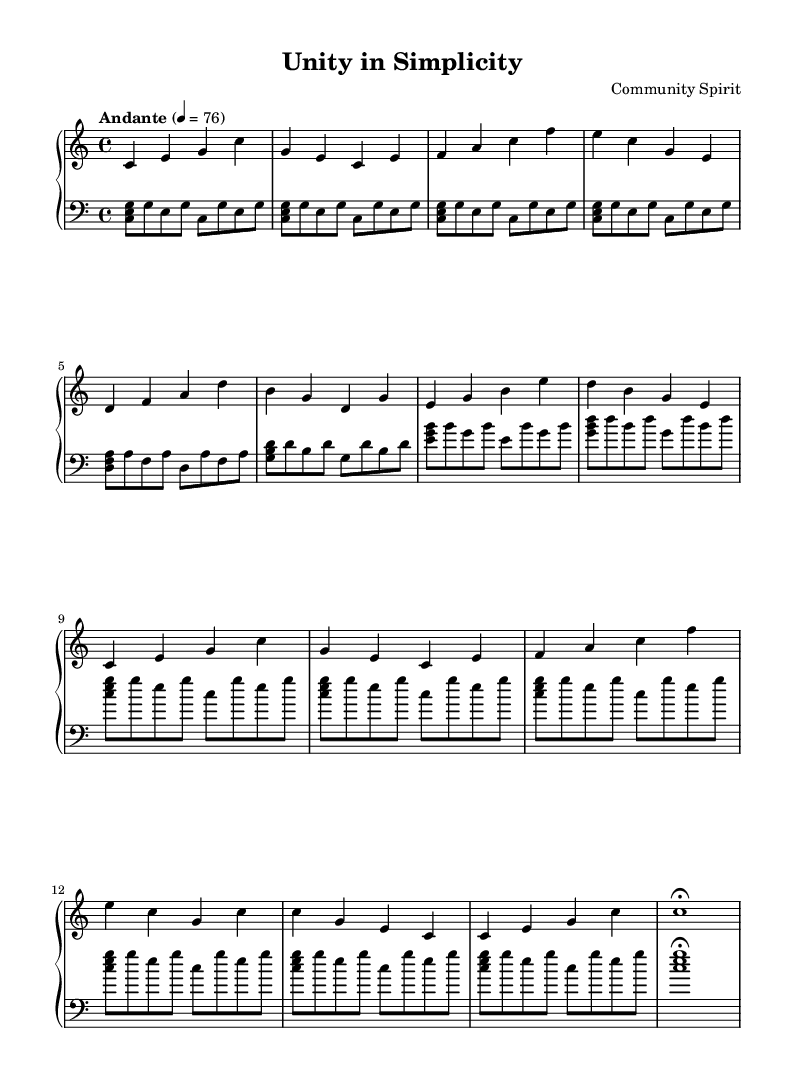What is the key signature of this music? The key signature indicates C major, which has no sharps or flats. This is identifiable by the absence of any accidental signs in the music staff.
Answer: C major What is the time signature of this piece? The time signature shown in the sheet music is 4/4, which is noted at the beginning. In 4/4, there are four beats in a measure, and a quarter note receives one beat.
Answer: 4/4 What is the tempo marking for this piece? The tempo marking is indicated as "Andante" with a metronome marking of quarter note = 76. This suggests a moderate pace suitable for reflective playing.
Answer: Andante How many sections are there in the music? The music is organized into three distinct sections: Section A, Section B, and Section A' followed by a Coda. This is determined by the labeling of each section in the notation.
Answer: 3 Which section is repeated the most in the piece? Section A is repeated the most frequently, occurring twice in its original form and once in a modified form (A'). This observation is made by counting the occurrences of each section in the music.
Answer: Section A What is the last note value in the Coda section? The last note in the Coda section is a whole note (c1) that has a fermata above it, indicating it should be held longer than its usual value. This is clarified by looking at the notation in the final measures.
Answer: Whole note 